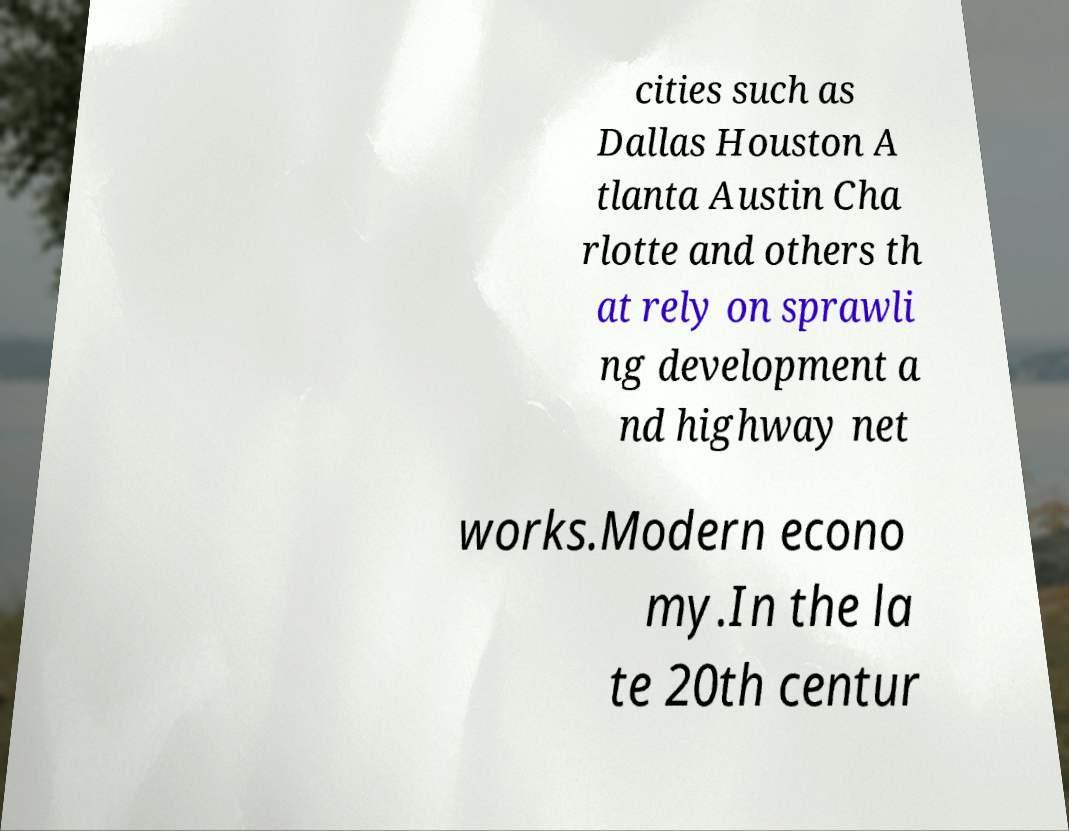Can you accurately transcribe the text from the provided image for me? cities such as Dallas Houston A tlanta Austin Cha rlotte and others th at rely on sprawli ng development a nd highway net works.Modern econo my.In the la te 20th centur 